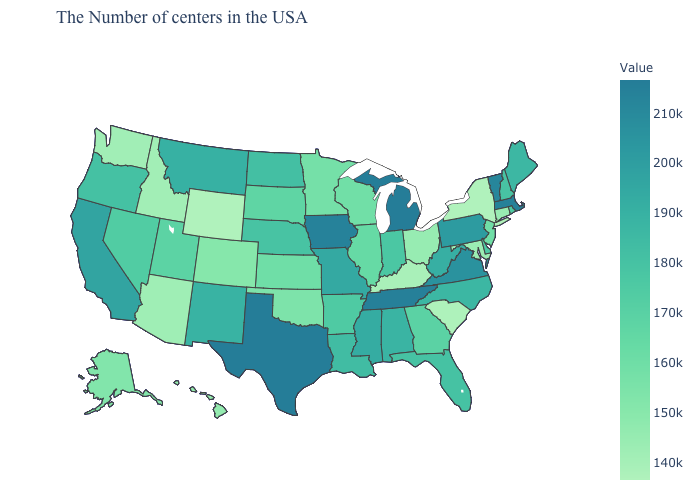Which states have the highest value in the USA?
Keep it brief. Michigan. Which states have the lowest value in the South?
Answer briefly. South Carolina. Among the states that border Wyoming , does Idaho have the lowest value?
Answer briefly. Yes. Does Wyoming have the lowest value in the USA?
Write a very short answer. Yes. 